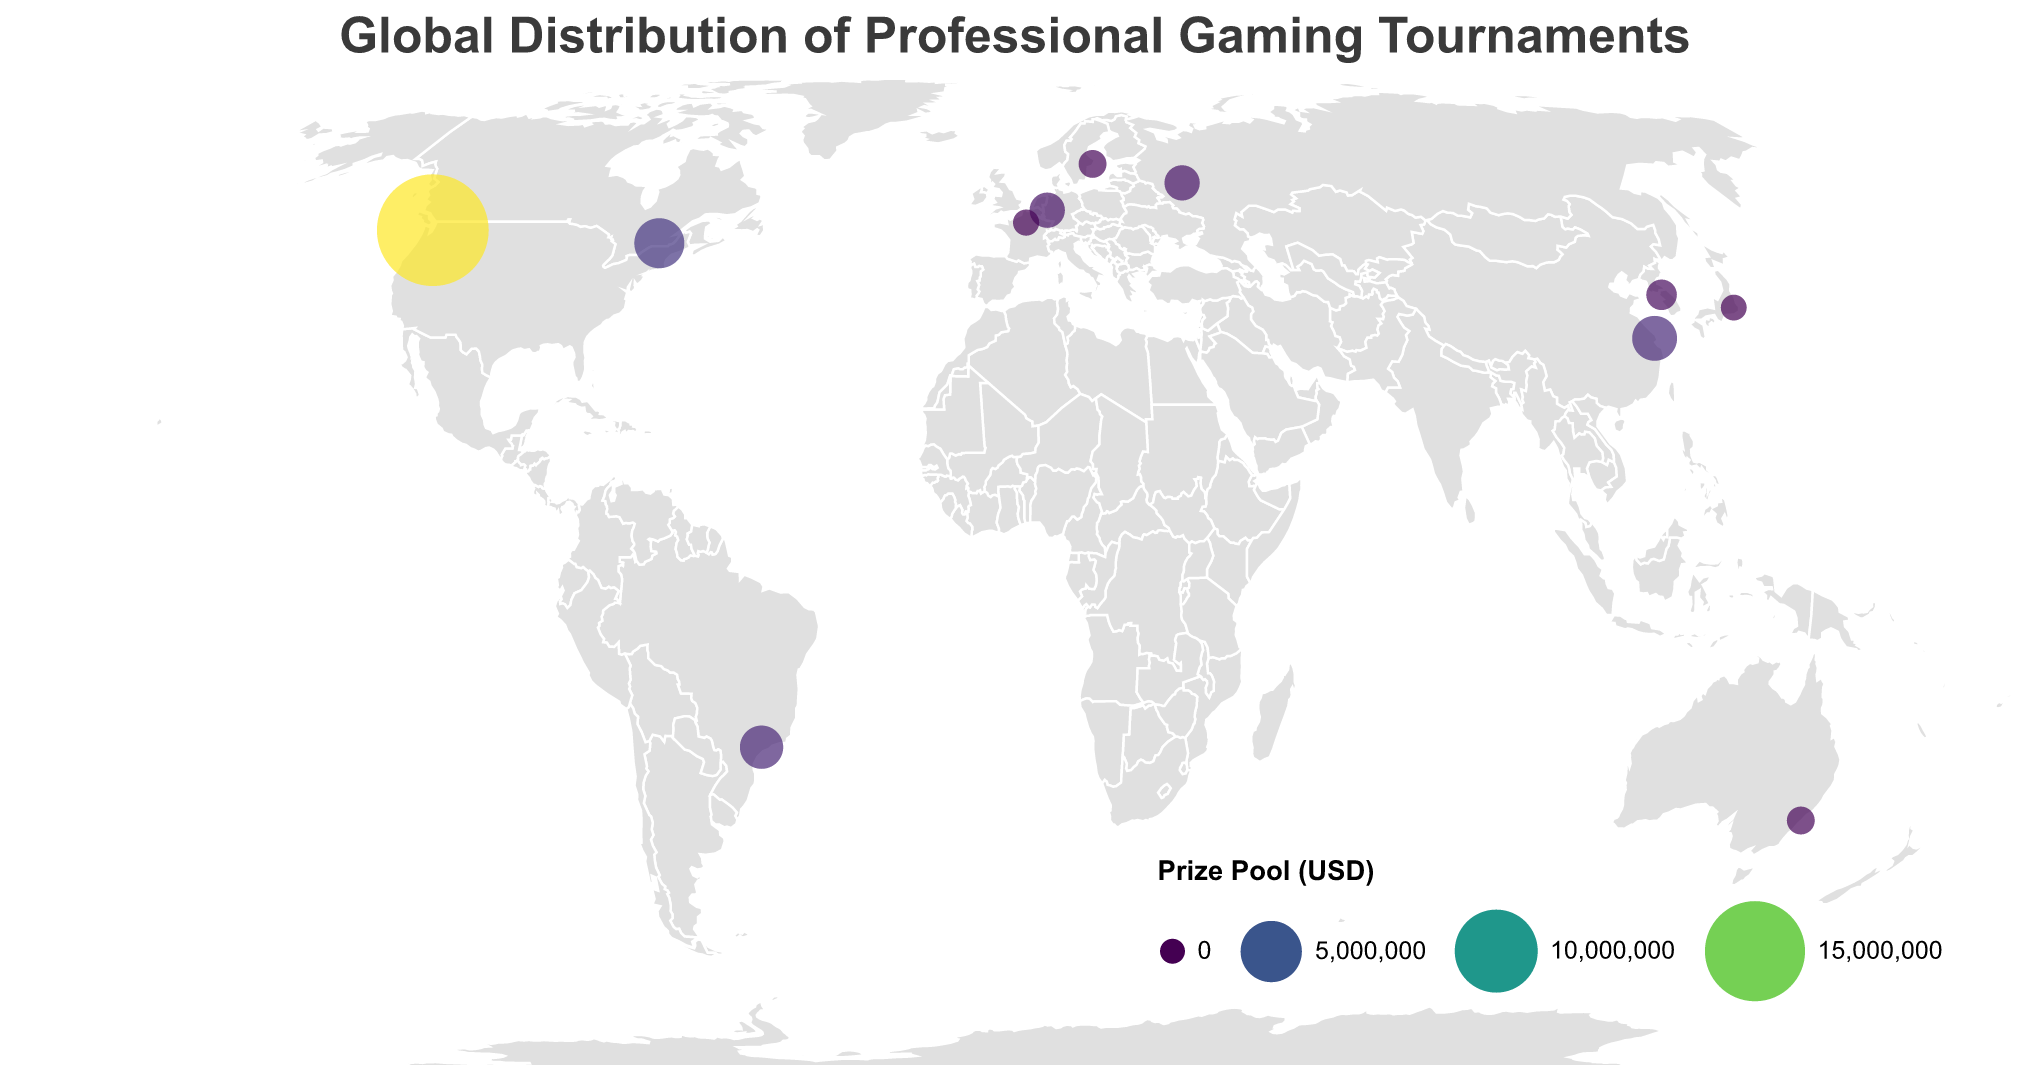What is the largest prize pool size shown in the figure? The largest circle represents the tournament with the largest prize pool size. By visually inspecting the size of the circles, the largest circle corresponds to "The International 2023" in the United States. The prize pool is $18,930,000.
Answer: $18,930,000 Which country has the smallest prize pool for a gaming tournament, and what is the tournament? The smallest circle on the plot indicates the smallest prize pool size. The smallest circle corresponds to "Evo Japan" in Japan, with a prize pool of $75,000.
Answer: Japan, Evo Japan How many professional gaming tournaments are represented in the plot? Count the number of circles on the map. Each circle represents one tournament.
Answer: 11 Which continent has the highest total prize pool amount? To find this, we sum the prize pool amounts for tournaments located in each continent. Comparing these sums, North America has the highest total due to the United States and Canada. The sums are as follows:
- North America: $18,930,000 (US) + $3,000,000 (Canada) = $21,930,000
- Asia: $2,225,000 (China) + $500,000 (South Korea) + $75,000 (Japan) = $2,800,000
- Europe: $1,000,000 (Germany) + $100,000 (France) + $250,000 (Sweden) + $1,000,000 (Russia) = $2,350,000
- South America: $2,000,000 (Brazil)
- Australia: $250,000
Thus, North America has the highest total prize pool.
Answer: North America Which two tournaments have the same prize pool size, and in which countries are they located? By checking the circles of similar sizes and verifying their prize pool values, "ESL One Cologne" in Germany and "EPICENTER Major" in Russia both have a prize pool of $1,000,000.
Answer: ESL One Cologne (Germany) and EPICENTER Major (Russia) What tournament in South America is represented and what is its prize pool size? There is only one circle in South America, located in Brazil. The tournament is "Free Fire World Series," with a prize pool of $2,000,000.
Answer: Free Fire World Series, $2,000,000 Which tournament has a prize pool size of $2,250,000, and where is it located? By checking the legend and circle sizes, the tournament with a prize pool of $2,250,000 is "League of Legends World Championship" in China.
Answer: League of Legends World Championship, China How does the prize pool size of the "Six Invitational" compare to that of the "StarCraft II World Championship Series"? Compare the prize pool sizes directly. The "Six Invitational" has a prize pool of $3,000,000, while "StarCraft II World Championship Series" has $500,000. The "Six Invitational" prize pool is significantly larger.
Answer: Six Invitational's prize pool is larger What is the average prize pool size of the tournaments shown on the figure? Sum all prize pools and divide by the number of tournaments: 
(18,930,000 + 2,225,000 + 500,000 + 1,000,000 + 250,000 + 2,000,000 + 100,000 + 250,000 + 75,000 + 1,000,000 + 3,000,000) ÷ 11. This equals $29,330,000 ÷ 11 ≈ $2,666,364
Answer: $2,666,364 